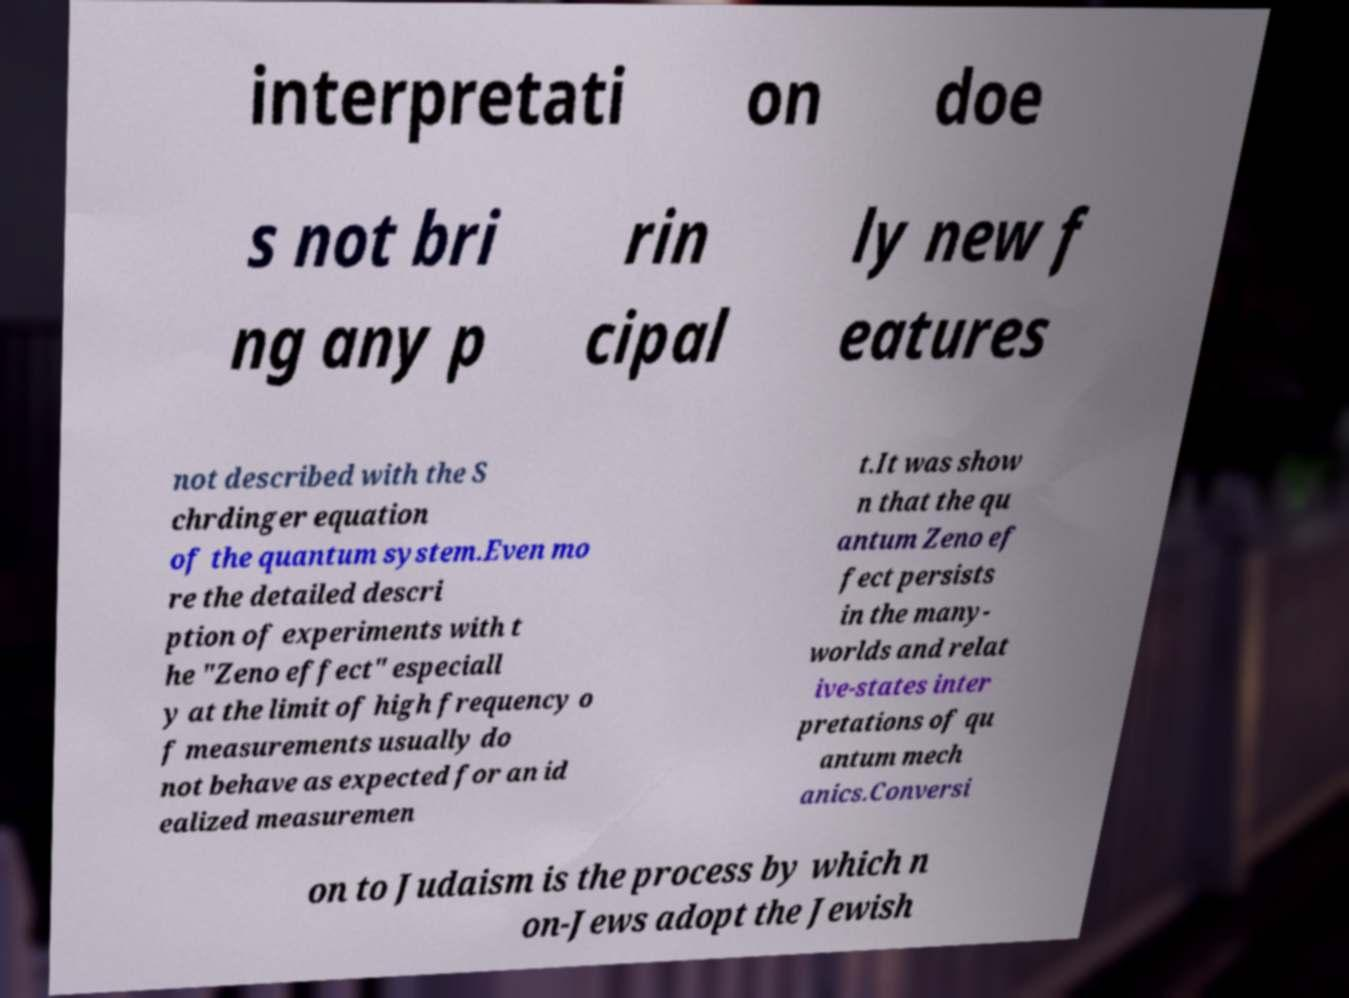There's text embedded in this image that I need extracted. Can you transcribe it verbatim? interpretati on doe s not bri ng any p rin cipal ly new f eatures not described with the S chrdinger equation of the quantum system.Even mo re the detailed descri ption of experiments with t he "Zeno effect" especiall y at the limit of high frequency o f measurements usually do not behave as expected for an id ealized measuremen t.It was show n that the qu antum Zeno ef fect persists in the many- worlds and relat ive-states inter pretations of qu antum mech anics.Conversi on to Judaism is the process by which n on-Jews adopt the Jewish 